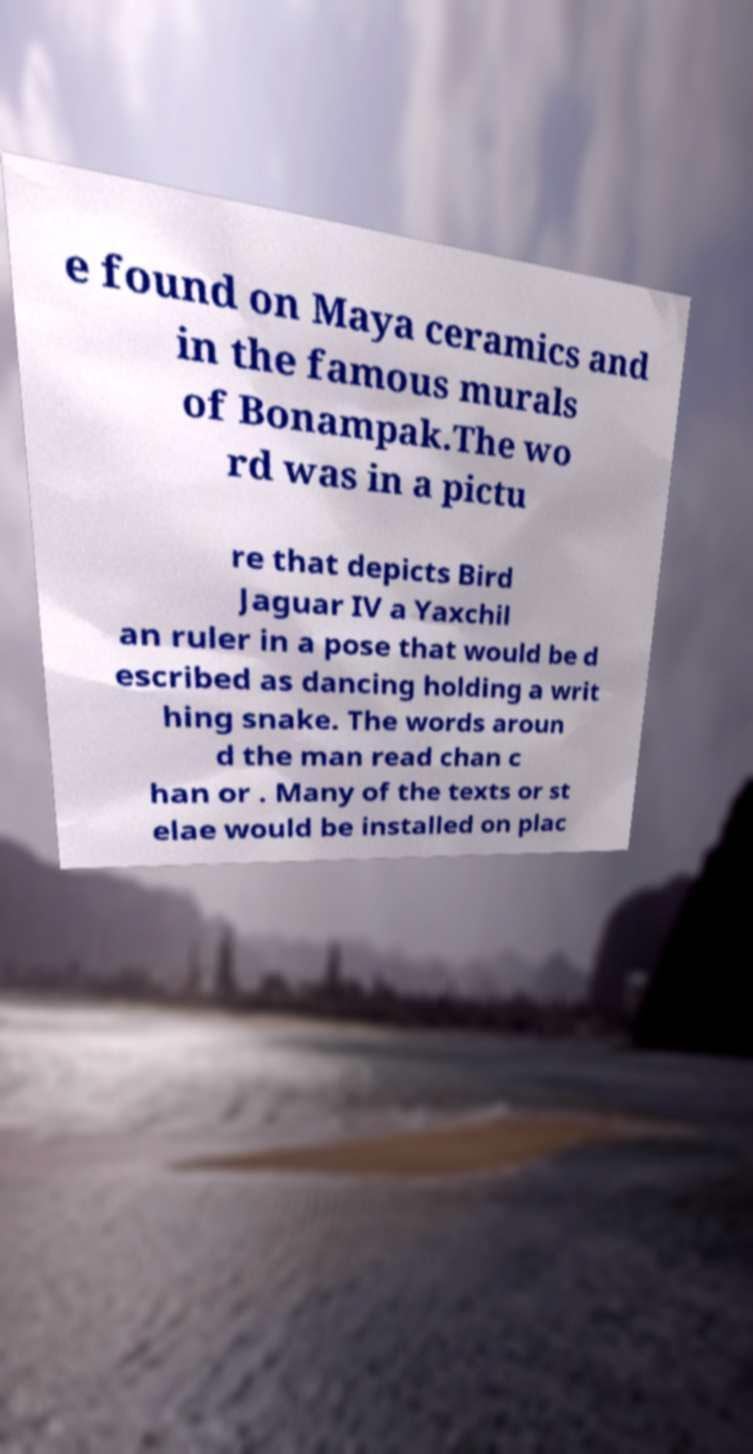What messages or text are displayed in this image? I need them in a readable, typed format. e found on Maya ceramics and in the famous murals of Bonampak.The wo rd was in a pictu re that depicts Bird Jaguar IV a Yaxchil an ruler in a pose that would be d escribed as dancing holding a writ hing snake. The words aroun d the man read chan c han or . Many of the texts or st elae would be installed on plac 